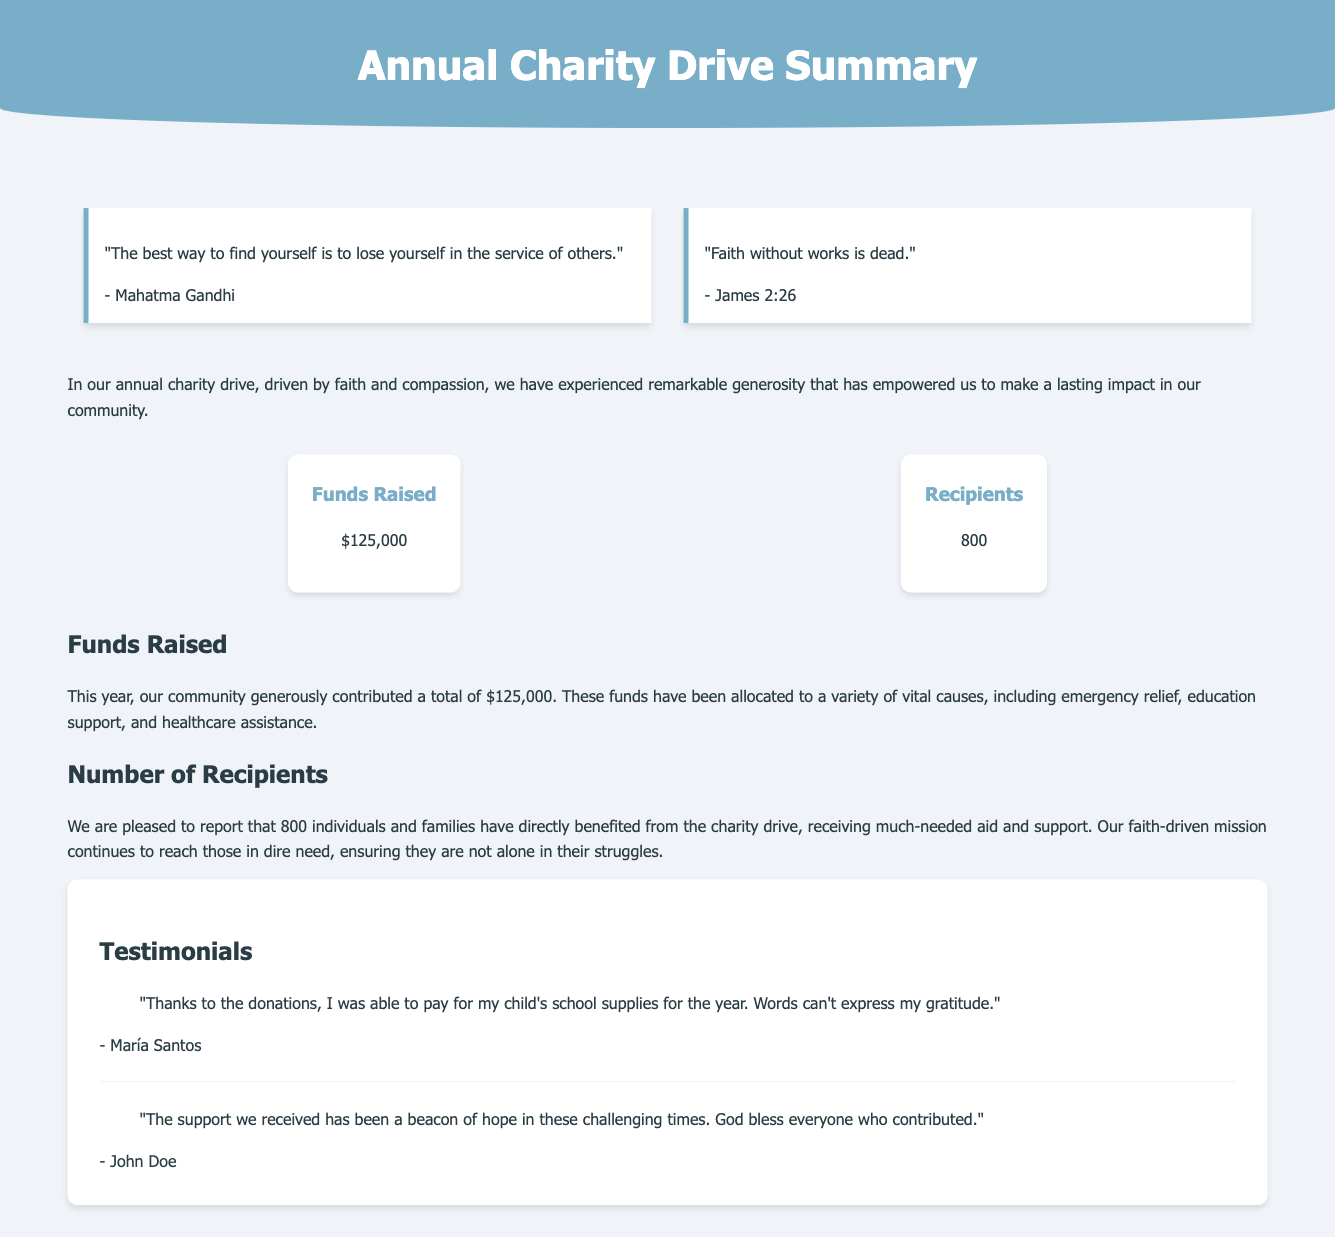What is the total amount raised? The total amount raised is mentioned in the metrics section as $125,000.
Answer: $125,000 How many recipients benefited from the charity drive? The number of recipients is stated in the metrics section as 800 individuals and families.
Answer: 800 Who is quoted in the first inspirational quote? The first quote is attributed to Mahatma Gandhi, as listed in the quote container.
Answer: Mahatma Gandhi What is the purpose of the funds raised? The funds are allocated to various vital causes, including emergency relief, education support, and healthcare assistance, as mentioned in the section about funds raised.
Answer: Emergency relief, education support, healthcare assistance What impact did the charity drive have on individuals? The drive positively affected individuals by providing aid and support to 800 beneficiaries as outlined in the document.
Answer: Aid and support to 800 beneficiaries What did María Santos express gratitude for? María Santos expressed gratitude for being able to pay for her child's school supplies, as noted in her testimonial.
Answer: School supplies How is the document structured in terms of themes? The themes include funds raised, recipients, and testimonials, organized into specific sections throughout the document.
Answer: Funds raised, recipients, testimonials What sentiment is expressed in John Doe's testimonial? John Doe's testimonial expresses hope and blessings towards those who contributed, indicating a positive sentiment.
Answer: Hope and blessings 